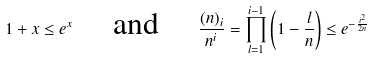Convert formula to latex. <formula><loc_0><loc_0><loc_500><loc_500>1 + x \leq e ^ { x } \quad \text { and } \quad \frac { ( n ) _ { i } } { n ^ { i } } = \prod _ { l = 1 } ^ { i - 1 } \left ( 1 - \frac { l } { n } \right ) \leq e ^ { - \frac { i ^ { 2 } } { 2 n } }</formula> 